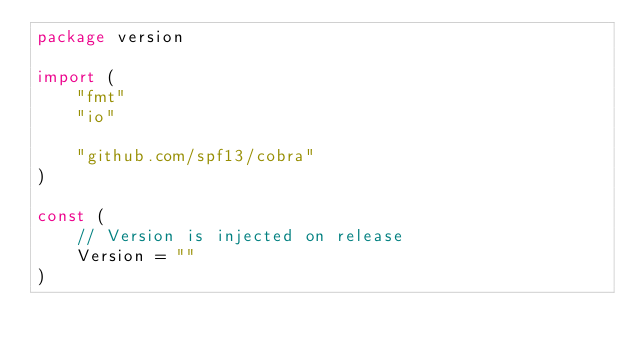Convert code to text. <code><loc_0><loc_0><loc_500><loc_500><_Go_>package version

import (
	"fmt"
	"io"

	"github.com/spf13/cobra"
)

const (
	// Version is injected on release
	Version = ""
)
</code> 